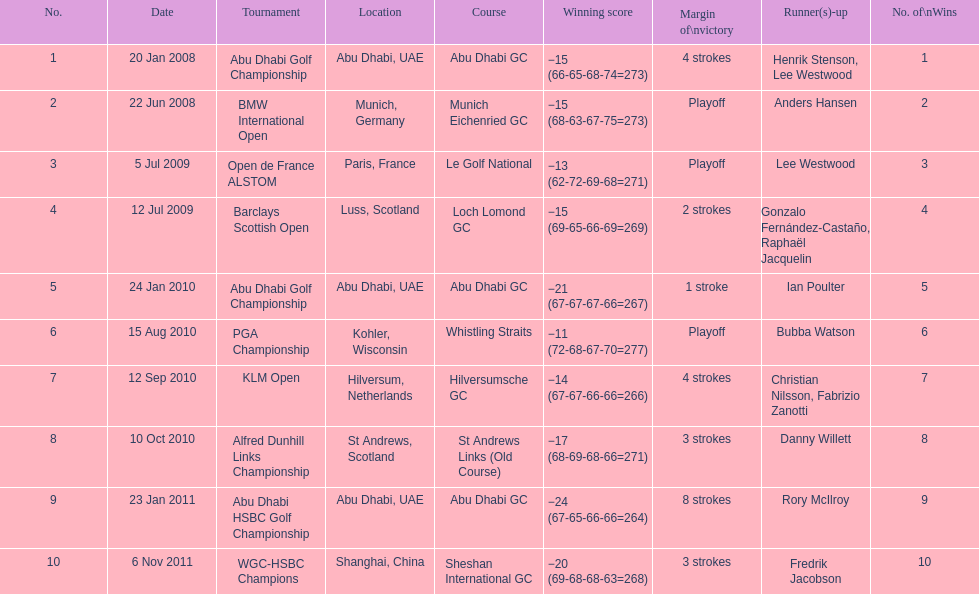How many winning scores were less than -14? 2. 